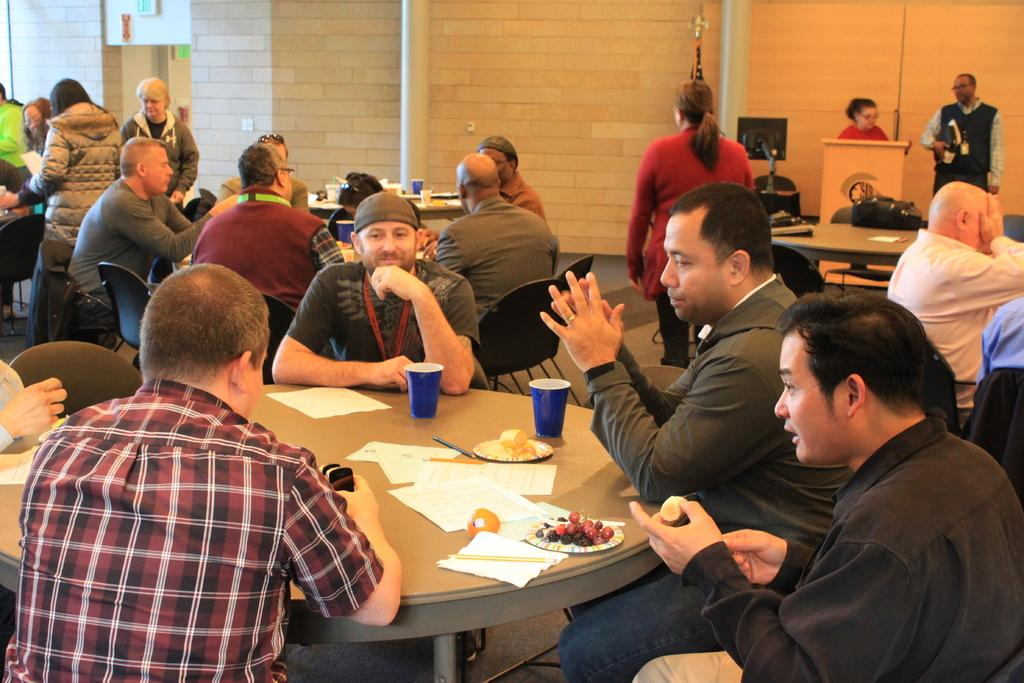What are the people in the image doing? The persons in the image are sitting and standing near to the tables. What can be seen at the top of the image? There is a wall at the top of the image. What items are present on the tables? There are papers, glasses, and plates on the tables. What type of knowledge is being shared in the cellar in the image? There is no cellar present in the image, and therefore no knowledge-sharing activity can be observed. 